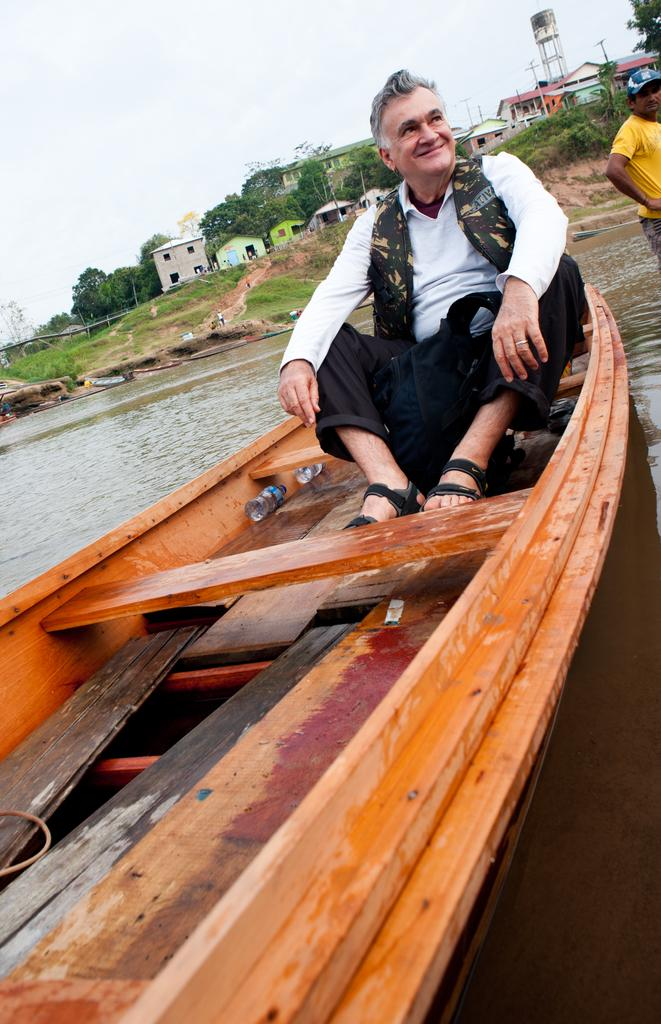What is the main subject of the image? The main subject of the image is a boat. Who is in the boat? A man is sitting in the boat. What is the man's expression? The man is smiling. What can be seen in the background of the image? There is water, a grass surface, houses, poles, trees, and the sky visible in the background. What time of day is it in the image? The time of day cannot be determined from the image alone. 